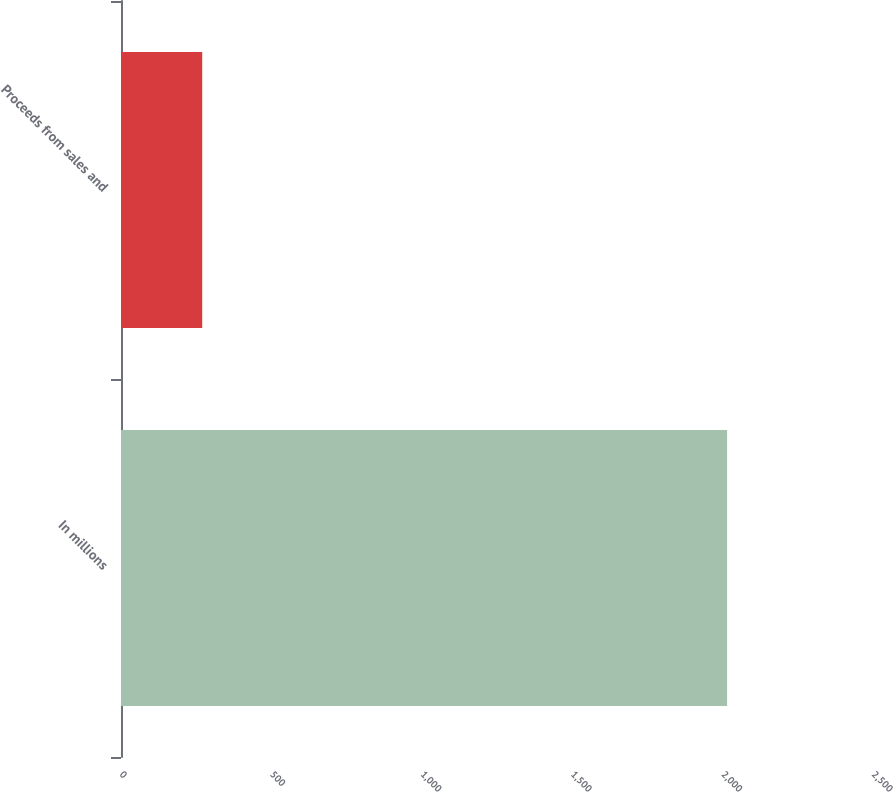Convert chart. <chart><loc_0><loc_0><loc_500><loc_500><bar_chart><fcel>In millions<fcel>Proceeds from sales and<nl><fcel>2015<fcel>270<nl></chart> 